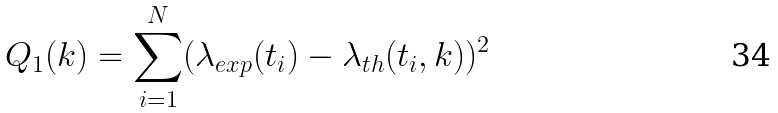<formula> <loc_0><loc_0><loc_500><loc_500>Q _ { 1 } ( k ) = \sum _ { i = 1 } ^ { N } ( \lambda _ { e x p } ( t _ { i } ) - \lambda _ { t h } ( t _ { i } , k ) ) ^ { 2 }</formula> 